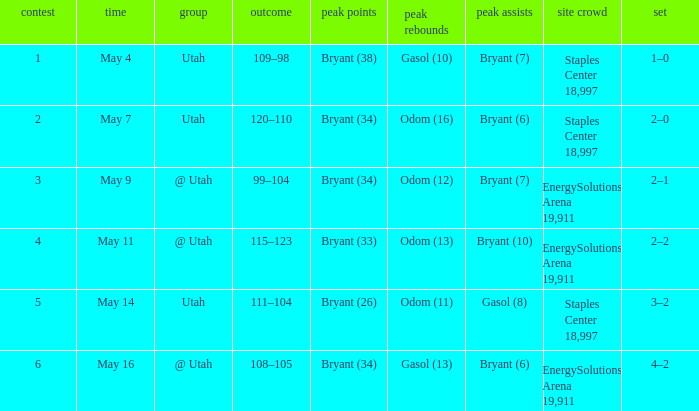What is the High rebounds with a High assists with bryant (7), and a Team of @ utah? Odom (12). 